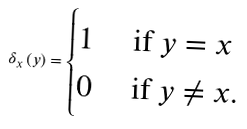<formula> <loc_0><loc_0><loc_500><loc_500>\delta _ { x } \left ( y \right ) = \begin{cases} 1 & \text { if } y = x \\ 0 & \text { if } y \ne x . \end{cases}</formula> 